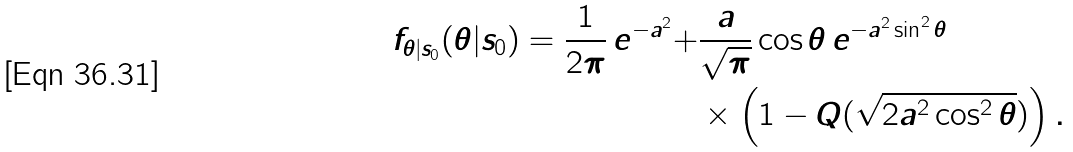Convert formula to latex. <formula><loc_0><loc_0><loc_500><loc_500>f _ { \theta | s _ { 0 } } ( \theta | s _ { 0 } ) = \frac { 1 } { 2 \pi } \, e ^ { - a ^ { 2 } } + & \frac { a } { \sqrt { \pi } } \cos \theta \, e ^ { - a ^ { 2 } \sin ^ { 2 } \theta } \\ & \times \left ( 1 - Q ( \sqrt { 2 a ^ { 2 } \cos ^ { 2 } \theta } ) \right ) .</formula> 